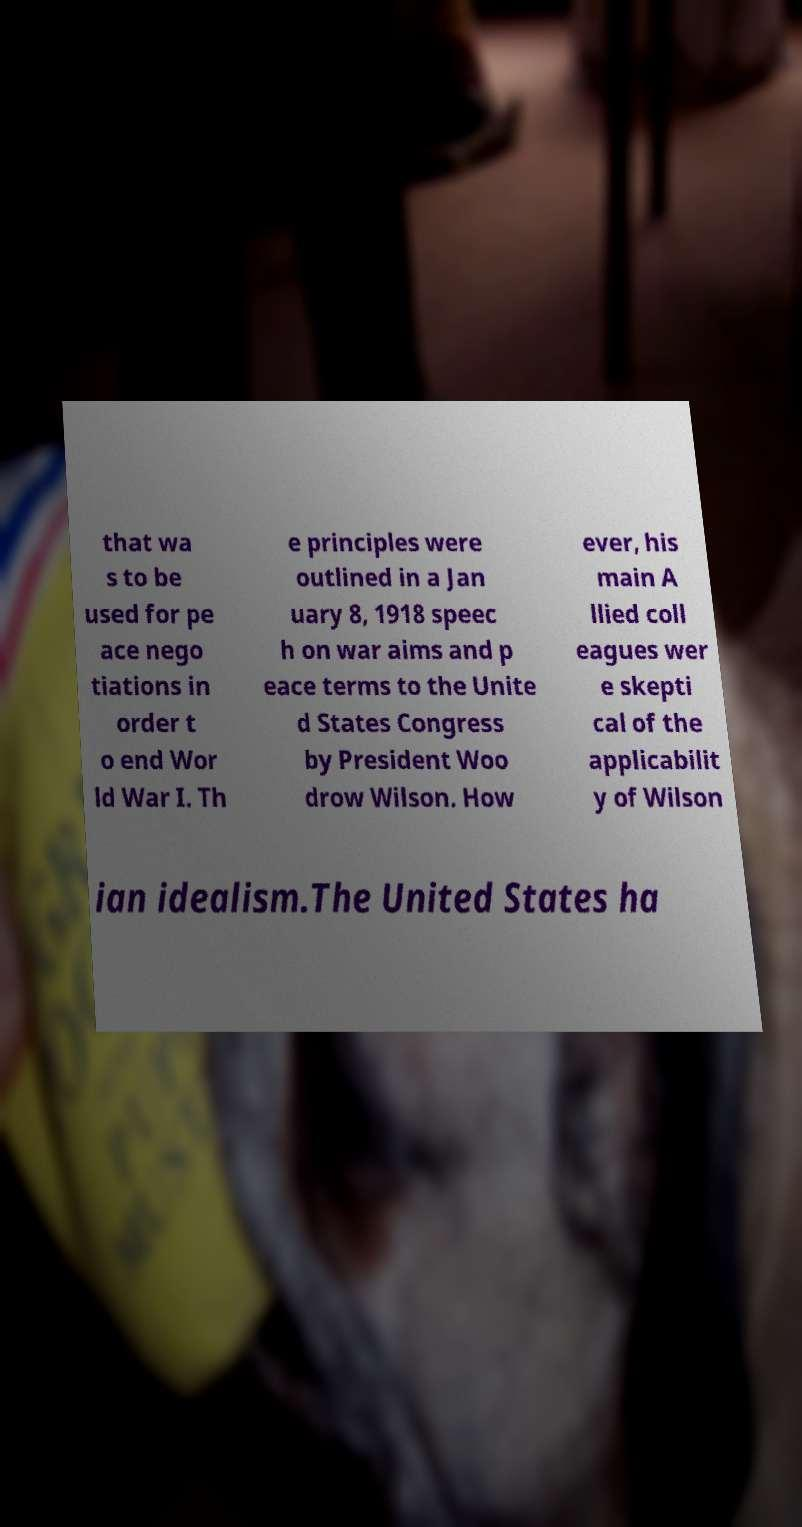Please identify and transcribe the text found in this image. that wa s to be used for pe ace nego tiations in order t o end Wor ld War I. Th e principles were outlined in a Jan uary 8, 1918 speec h on war aims and p eace terms to the Unite d States Congress by President Woo drow Wilson. How ever, his main A llied coll eagues wer e skepti cal of the applicabilit y of Wilson ian idealism.The United States ha 